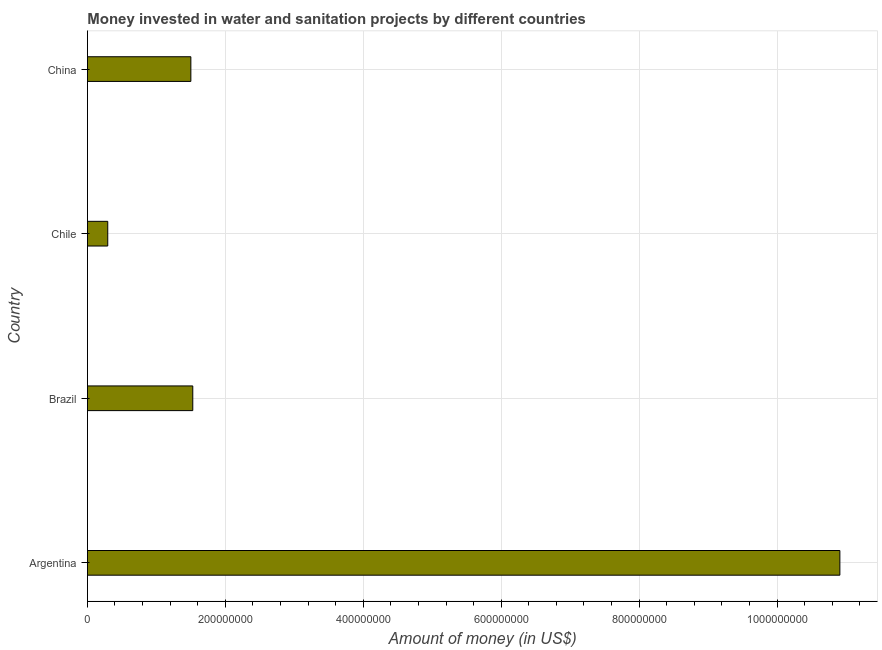Does the graph contain any zero values?
Ensure brevity in your answer.  No. Does the graph contain grids?
Your answer should be very brief. Yes. What is the title of the graph?
Your answer should be very brief. Money invested in water and sanitation projects by different countries. What is the label or title of the X-axis?
Ensure brevity in your answer.  Amount of money (in US$). What is the investment in China?
Offer a terse response. 1.50e+08. Across all countries, what is the maximum investment?
Ensure brevity in your answer.  1.09e+09. Across all countries, what is the minimum investment?
Provide a short and direct response. 2.95e+07. In which country was the investment minimum?
Provide a succinct answer. Chile. What is the sum of the investment?
Your answer should be compact. 1.42e+09. What is the difference between the investment in Brazil and China?
Provide a succinct answer. 2.80e+06. What is the average investment per country?
Your answer should be very brief. 3.56e+08. What is the median investment?
Your answer should be compact. 1.51e+08. What is the ratio of the investment in Argentina to that in Chile?
Your answer should be compact. 36.98. Is the investment in Brazil less than that in China?
Offer a terse response. No. What is the difference between the highest and the second highest investment?
Keep it short and to the point. 9.38e+08. Is the sum of the investment in Brazil and China greater than the maximum investment across all countries?
Your answer should be compact. No. What is the difference between the highest and the lowest investment?
Your answer should be very brief. 1.06e+09. In how many countries, is the investment greater than the average investment taken over all countries?
Your answer should be very brief. 1. How many bars are there?
Ensure brevity in your answer.  4. Are all the bars in the graph horizontal?
Make the answer very short. Yes. Are the values on the major ticks of X-axis written in scientific E-notation?
Provide a short and direct response. No. What is the Amount of money (in US$) of Argentina?
Your response must be concise. 1.09e+09. What is the Amount of money (in US$) of Brazil?
Give a very brief answer. 1.53e+08. What is the Amount of money (in US$) in Chile?
Your response must be concise. 2.95e+07. What is the Amount of money (in US$) of China?
Make the answer very short. 1.50e+08. What is the difference between the Amount of money (in US$) in Argentina and Brazil?
Your response must be concise. 9.38e+08. What is the difference between the Amount of money (in US$) in Argentina and Chile?
Your response must be concise. 1.06e+09. What is the difference between the Amount of money (in US$) in Argentina and China?
Give a very brief answer. 9.41e+08. What is the difference between the Amount of money (in US$) in Brazil and Chile?
Provide a short and direct response. 1.23e+08. What is the difference between the Amount of money (in US$) in Brazil and China?
Give a very brief answer. 2.80e+06. What is the difference between the Amount of money (in US$) in Chile and China?
Provide a succinct answer. -1.20e+08. What is the ratio of the Amount of money (in US$) in Argentina to that in Brazil?
Give a very brief answer. 7.14. What is the ratio of the Amount of money (in US$) in Argentina to that in Chile?
Keep it short and to the point. 36.98. What is the ratio of the Amount of money (in US$) in Argentina to that in China?
Provide a short and direct response. 7.27. What is the ratio of the Amount of money (in US$) in Brazil to that in Chile?
Keep it short and to the point. 5.18. What is the ratio of the Amount of money (in US$) in Brazil to that in China?
Provide a short and direct response. 1.02. What is the ratio of the Amount of money (in US$) in Chile to that in China?
Offer a very short reply. 0.2. 